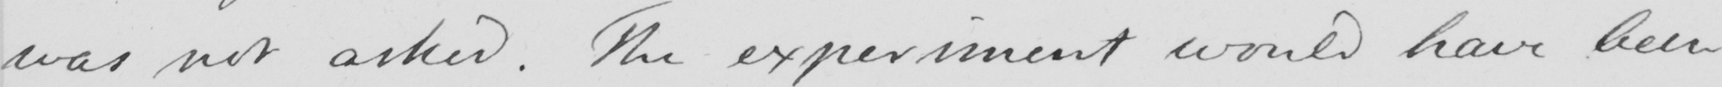Transcribe the text shown in this historical manuscript line. was not asked . The experiment would have been 